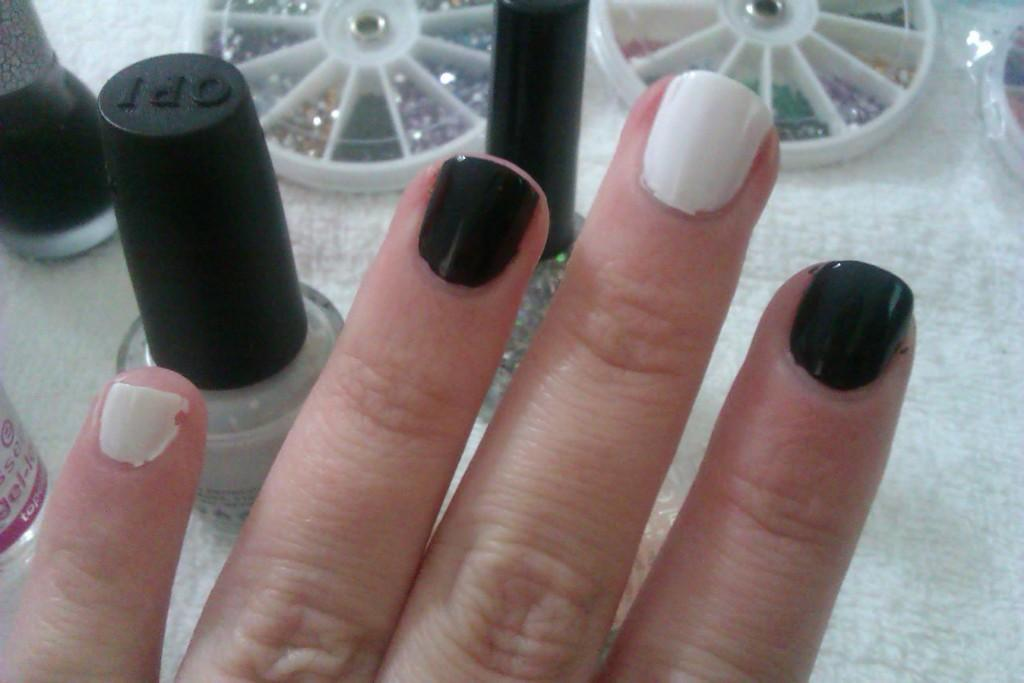What body part is visible in the image? There are fingers visible in the image. What items can be seen in the image related to the fingers? There are nail polish bottles in the image. What is the setting of the image? The image shows objects on a table. What boundary is visible in the image? There is no boundary visible in the image. 